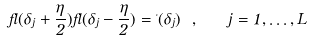Convert formula to latex. <formula><loc_0><loc_0><loc_500><loc_500>\Lambda ( \delta _ { j } + \frac { \eta } { 2 } ) \Lambda ( \delta _ { j } - \frac { \eta } { 2 } ) = \Delta ( \delta _ { j } ) \ , \quad j = 1 , \dots , L</formula> 